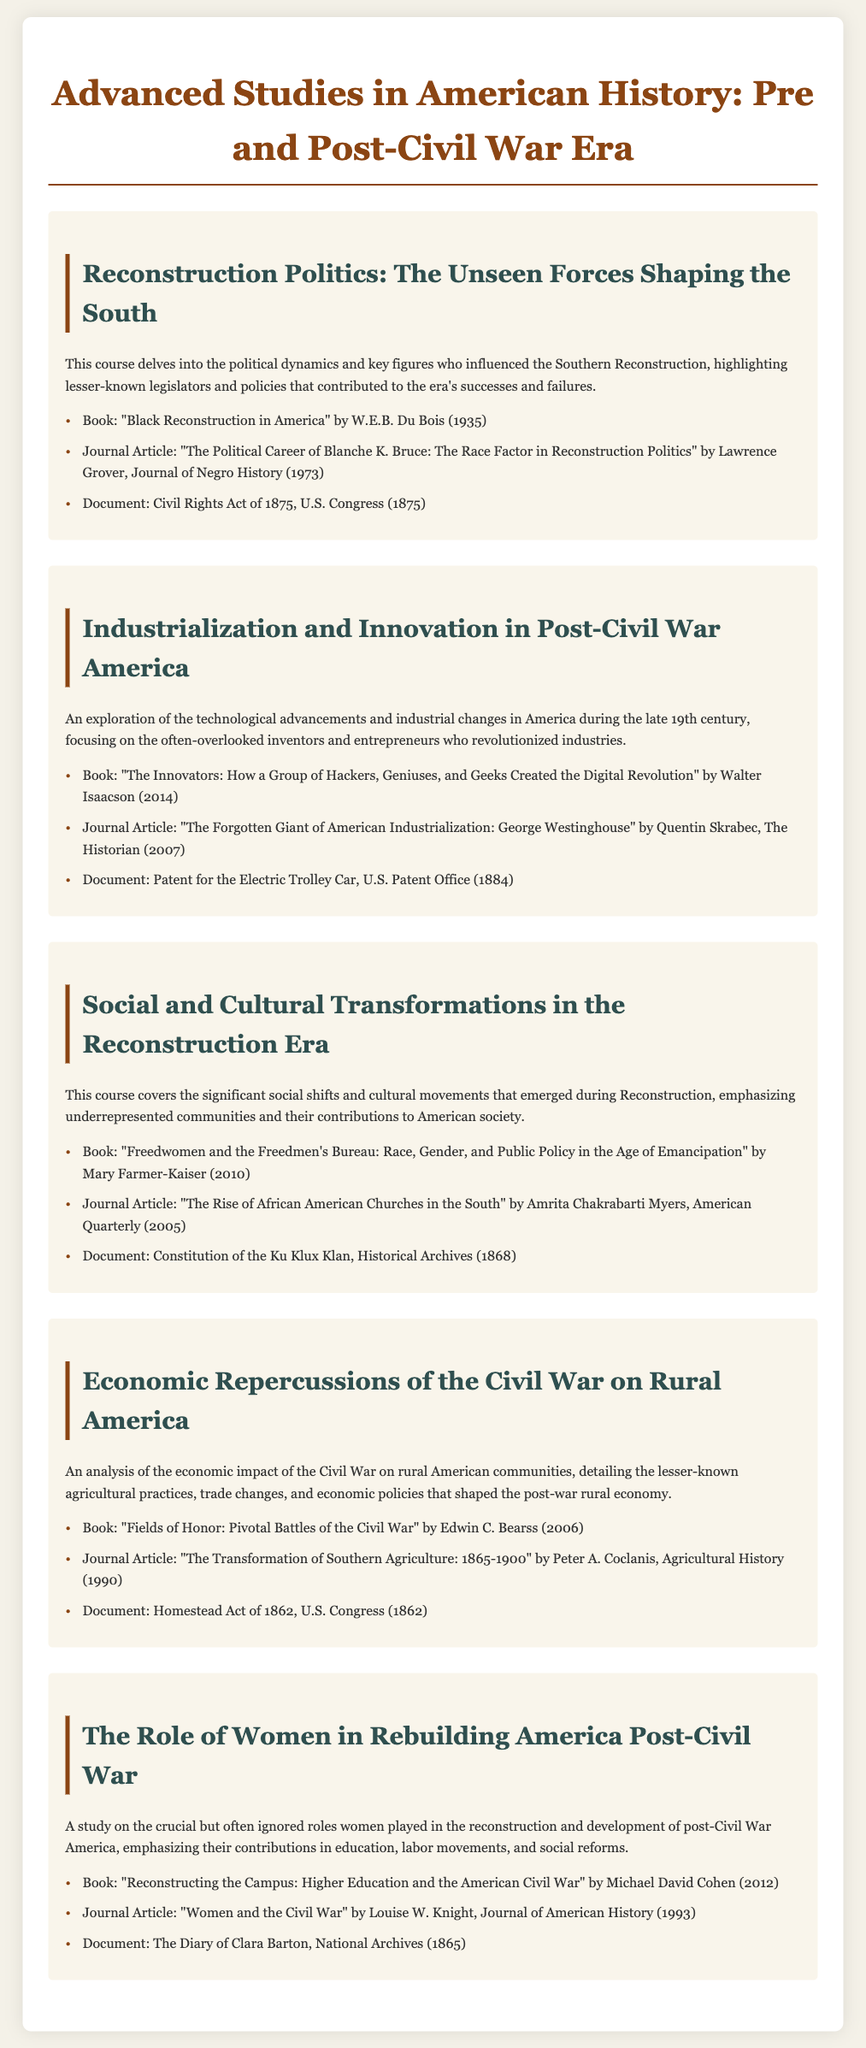What is the title of the first topic? The title of the first topic is found at the header of the section, which discusses Reconstruction Politics.
Answer: Reconstruction Politics: The Unseen Forces Shaping the South Who authored "Black Reconstruction in America"? The author's name is mentioned in the list of materials for the first topic of the syllabus.
Answer: W.E.B. Du Bois What year was the Civil Rights Act passed? The year is specified alongside the document title under the materials for the first topic.
Answer: 1875 Which community's rise does Amrita Chakrabarti Myers explore? The question refers to the subject of her journal article mentioned in the second topic.
Answer: African American Churches What is the main focus of the course on Industrialization? The primary aspect of this course is mentioned in the introductory description of the topic.
Answer: Technological advancements and industrial changes What 1862 act is referenced in the Economic topic? The act is listed among the materials in the fourth topic, indicating its significance to economic changes.
Answer: Homestead Act In what year was the document "The Diary of Clara Barton" created? The year is provided alongside the title in the fifth topic's materials.
Answer: 1865 What role did women play in post-Civil War America? The response is derived from the stated focus of the last topic in the syllabus.
Answer: Education, labor movements, social reforms Who analyzed the economic impact of the Civil War on rural communities? This refers to the author mentioned in the journal article of the fourth topic.
Answer: Peter A. Coclanis 